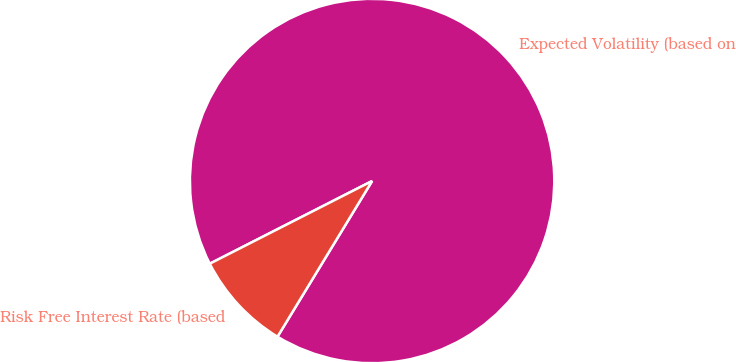Convert chart to OTSL. <chart><loc_0><loc_0><loc_500><loc_500><pie_chart><fcel>Expected Volatility (based on<fcel>Risk Free Interest Rate (based<nl><fcel>91.19%<fcel>8.81%<nl></chart> 